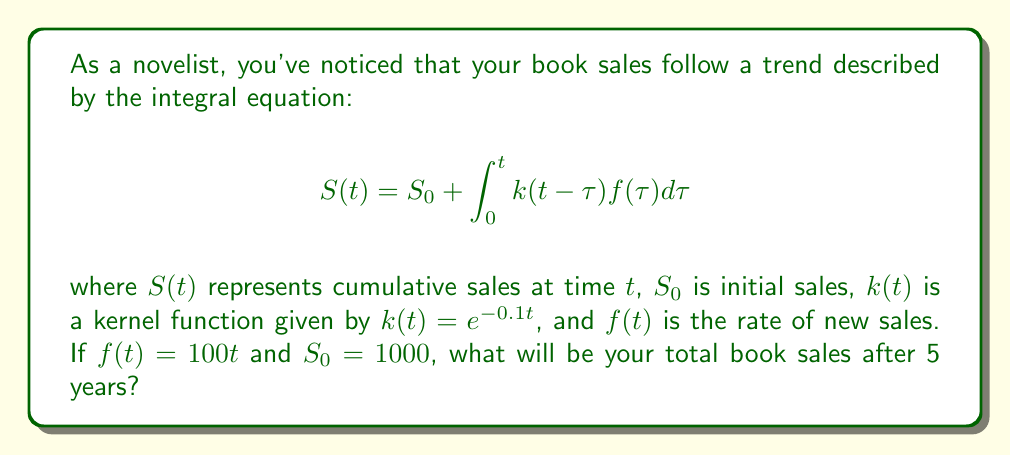Can you solve this math problem? Let's solve this step-by-step:

1) We need to evaluate $S(5)$ using the given integral equation:

   $$S(5) = 1000 + \int_0^5 e^{-0.1(5-\tau)}(100\tau)d\tau$$

2) Let's simplify the integrand:

   $$S(5) = 1000 + 100e^{-0.5}\int_0^5 e^{0.1\tau}\tau d\tau$$

3) To solve this integral, we can use integration by parts. Let $u = \tau$ and $dv = e^{0.1\tau}d\tau$:

   $$S(5) = 1000 + 100e^{-0.5}[10\tau e^{0.1\tau}|_0^5 - 10\int_0^5 e^{0.1\tau}d\tau]$$

4) Evaluate the first part:

   $$S(5) = 1000 + 100e^{-0.5}[50e^{0.5} - 0 - 10\int_0^5 e^{0.1\tau}d\tau]$$

5) Solve the remaining integral:

   $$S(5) = 1000 + 100e^{-0.5}[50e^{0.5} - 100(e^{0.5} - 1)]$$

6) Simplify:

   $$S(5) = 1000 + 100[50 - 100 + 100e^{-0.5}]$$
   $$S(5) = 1000 + 5000 - 10000 + 100e^{-0.5}100$$
   $$S(5) = -4000 + 6065.31$$

7) Calculate the final result:

   $$S(5) = 2065.31$$
Answer: 2065 books 